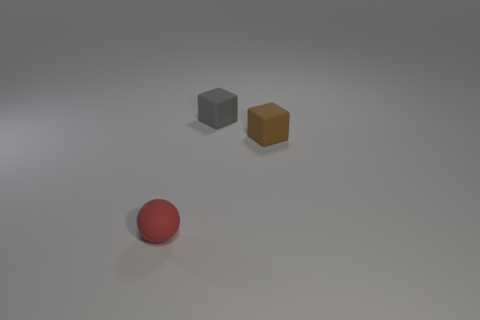Can you guess the relative weights of the objects? While it's only a guess without physical interaction, the grey cube likely weighs the most due to its size, followed by the brown cube, with the red sphere being the lightest. 